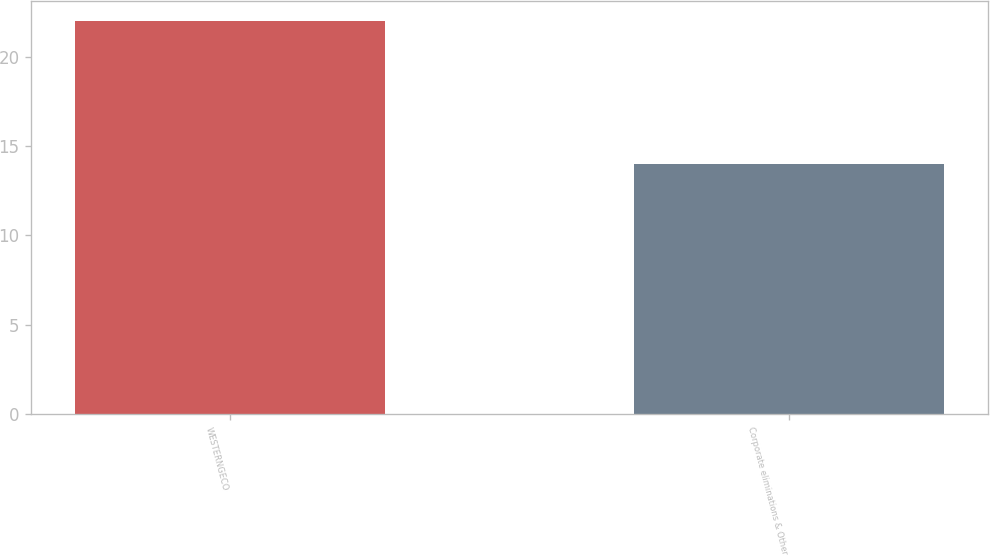Convert chart. <chart><loc_0><loc_0><loc_500><loc_500><bar_chart><fcel>WESTERNGECO<fcel>Corporate eliminations & Other<nl><fcel>22<fcel>14<nl></chart> 